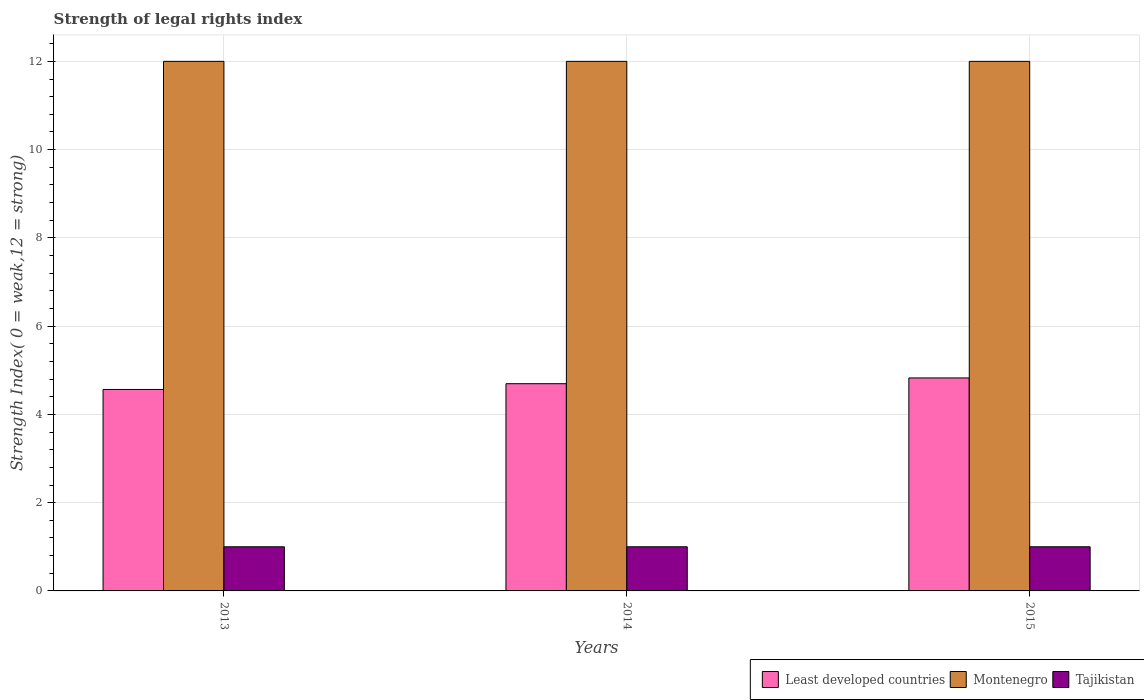How many different coloured bars are there?
Ensure brevity in your answer.  3. How many groups of bars are there?
Your response must be concise. 3. Are the number of bars per tick equal to the number of legend labels?
Your response must be concise. Yes. Are the number of bars on each tick of the X-axis equal?
Your answer should be very brief. Yes. What is the label of the 3rd group of bars from the left?
Your response must be concise. 2015. In how many cases, is the number of bars for a given year not equal to the number of legend labels?
Your answer should be very brief. 0. What is the strength index in Tajikistan in 2015?
Your response must be concise. 1. Across all years, what is the maximum strength index in Least developed countries?
Provide a short and direct response. 4.83. Across all years, what is the minimum strength index in Montenegro?
Your response must be concise. 12. In which year was the strength index in Least developed countries maximum?
Your answer should be very brief. 2015. What is the total strength index in Tajikistan in the graph?
Keep it short and to the point. 3. What is the difference between the strength index in Montenegro in 2015 and the strength index in Least developed countries in 2014?
Give a very brief answer. 7.3. What is the average strength index in Montenegro per year?
Ensure brevity in your answer.  12. In the year 2013, what is the difference between the strength index in Montenegro and strength index in Tajikistan?
Provide a succinct answer. 11. What is the ratio of the strength index in Least developed countries in 2013 to that in 2014?
Provide a short and direct response. 0.97. What is the difference between the highest and the second highest strength index in Montenegro?
Give a very brief answer. 0. What is the difference between the highest and the lowest strength index in Montenegro?
Offer a very short reply. 0. What does the 1st bar from the left in 2014 represents?
Your answer should be compact. Least developed countries. What does the 2nd bar from the right in 2013 represents?
Offer a terse response. Montenegro. Are all the bars in the graph horizontal?
Provide a short and direct response. No. Where does the legend appear in the graph?
Offer a very short reply. Bottom right. How many legend labels are there?
Make the answer very short. 3. How are the legend labels stacked?
Your answer should be compact. Horizontal. What is the title of the graph?
Offer a very short reply. Strength of legal rights index. Does "Togo" appear as one of the legend labels in the graph?
Your answer should be very brief. No. What is the label or title of the Y-axis?
Give a very brief answer. Strength Index( 0 = weak,12 = strong). What is the Strength Index( 0 = weak,12 = strong) of Least developed countries in 2013?
Provide a short and direct response. 4.57. What is the Strength Index( 0 = weak,12 = strong) of Least developed countries in 2014?
Your response must be concise. 4.7. What is the Strength Index( 0 = weak,12 = strong) of Tajikistan in 2014?
Offer a terse response. 1. What is the Strength Index( 0 = weak,12 = strong) in Least developed countries in 2015?
Offer a very short reply. 4.83. What is the Strength Index( 0 = weak,12 = strong) in Montenegro in 2015?
Your answer should be compact. 12. Across all years, what is the maximum Strength Index( 0 = weak,12 = strong) in Least developed countries?
Ensure brevity in your answer.  4.83. Across all years, what is the minimum Strength Index( 0 = weak,12 = strong) of Least developed countries?
Your answer should be compact. 4.57. What is the total Strength Index( 0 = weak,12 = strong) in Least developed countries in the graph?
Ensure brevity in your answer.  14.09. What is the total Strength Index( 0 = weak,12 = strong) of Montenegro in the graph?
Your response must be concise. 36. What is the total Strength Index( 0 = weak,12 = strong) of Tajikistan in the graph?
Offer a very short reply. 3. What is the difference between the Strength Index( 0 = weak,12 = strong) in Least developed countries in 2013 and that in 2014?
Give a very brief answer. -0.13. What is the difference between the Strength Index( 0 = weak,12 = strong) in Least developed countries in 2013 and that in 2015?
Provide a short and direct response. -0.26. What is the difference between the Strength Index( 0 = weak,12 = strong) of Montenegro in 2013 and that in 2015?
Your answer should be compact. 0. What is the difference between the Strength Index( 0 = weak,12 = strong) in Tajikistan in 2013 and that in 2015?
Keep it short and to the point. 0. What is the difference between the Strength Index( 0 = weak,12 = strong) of Least developed countries in 2014 and that in 2015?
Give a very brief answer. -0.13. What is the difference between the Strength Index( 0 = weak,12 = strong) of Tajikistan in 2014 and that in 2015?
Give a very brief answer. 0. What is the difference between the Strength Index( 0 = weak,12 = strong) of Least developed countries in 2013 and the Strength Index( 0 = weak,12 = strong) of Montenegro in 2014?
Give a very brief answer. -7.43. What is the difference between the Strength Index( 0 = weak,12 = strong) in Least developed countries in 2013 and the Strength Index( 0 = weak,12 = strong) in Tajikistan in 2014?
Keep it short and to the point. 3.57. What is the difference between the Strength Index( 0 = weak,12 = strong) in Least developed countries in 2013 and the Strength Index( 0 = weak,12 = strong) in Montenegro in 2015?
Keep it short and to the point. -7.43. What is the difference between the Strength Index( 0 = weak,12 = strong) of Least developed countries in 2013 and the Strength Index( 0 = weak,12 = strong) of Tajikistan in 2015?
Keep it short and to the point. 3.57. What is the difference between the Strength Index( 0 = weak,12 = strong) in Least developed countries in 2014 and the Strength Index( 0 = weak,12 = strong) in Montenegro in 2015?
Your answer should be very brief. -7.3. What is the difference between the Strength Index( 0 = weak,12 = strong) of Least developed countries in 2014 and the Strength Index( 0 = weak,12 = strong) of Tajikistan in 2015?
Give a very brief answer. 3.7. What is the average Strength Index( 0 = weak,12 = strong) of Least developed countries per year?
Provide a succinct answer. 4.7. What is the average Strength Index( 0 = weak,12 = strong) of Tajikistan per year?
Your answer should be compact. 1. In the year 2013, what is the difference between the Strength Index( 0 = weak,12 = strong) in Least developed countries and Strength Index( 0 = weak,12 = strong) in Montenegro?
Offer a terse response. -7.43. In the year 2013, what is the difference between the Strength Index( 0 = weak,12 = strong) in Least developed countries and Strength Index( 0 = weak,12 = strong) in Tajikistan?
Give a very brief answer. 3.57. In the year 2013, what is the difference between the Strength Index( 0 = weak,12 = strong) in Montenegro and Strength Index( 0 = weak,12 = strong) in Tajikistan?
Offer a very short reply. 11. In the year 2014, what is the difference between the Strength Index( 0 = weak,12 = strong) of Least developed countries and Strength Index( 0 = weak,12 = strong) of Montenegro?
Provide a short and direct response. -7.3. In the year 2014, what is the difference between the Strength Index( 0 = weak,12 = strong) in Least developed countries and Strength Index( 0 = weak,12 = strong) in Tajikistan?
Your answer should be compact. 3.7. In the year 2014, what is the difference between the Strength Index( 0 = weak,12 = strong) in Montenegro and Strength Index( 0 = weak,12 = strong) in Tajikistan?
Provide a short and direct response. 11. In the year 2015, what is the difference between the Strength Index( 0 = weak,12 = strong) of Least developed countries and Strength Index( 0 = weak,12 = strong) of Montenegro?
Offer a very short reply. -7.17. In the year 2015, what is the difference between the Strength Index( 0 = weak,12 = strong) of Least developed countries and Strength Index( 0 = weak,12 = strong) of Tajikistan?
Make the answer very short. 3.83. In the year 2015, what is the difference between the Strength Index( 0 = weak,12 = strong) of Montenegro and Strength Index( 0 = weak,12 = strong) of Tajikistan?
Provide a short and direct response. 11. What is the ratio of the Strength Index( 0 = weak,12 = strong) in Least developed countries in 2013 to that in 2014?
Provide a short and direct response. 0.97. What is the ratio of the Strength Index( 0 = weak,12 = strong) of Montenegro in 2013 to that in 2014?
Keep it short and to the point. 1. What is the ratio of the Strength Index( 0 = weak,12 = strong) in Tajikistan in 2013 to that in 2014?
Your response must be concise. 1. What is the ratio of the Strength Index( 0 = weak,12 = strong) of Least developed countries in 2013 to that in 2015?
Your answer should be compact. 0.95. What is the ratio of the Strength Index( 0 = weak,12 = strong) of Least developed countries in 2014 to that in 2015?
Offer a terse response. 0.97. What is the ratio of the Strength Index( 0 = weak,12 = strong) of Tajikistan in 2014 to that in 2015?
Your answer should be compact. 1. What is the difference between the highest and the second highest Strength Index( 0 = weak,12 = strong) of Least developed countries?
Provide a succinct answer. 0.13. What is the difference between the highest and the lowest Strength Index( 0 = weak,12 = strong) in Least developed countries?
Your answer should be compact. 0.26. What is the difference between the highest and the lowest Strength Index( 0 = weak,12 = strong) in Tajikistan?
Keep it short and to the point. 0. 